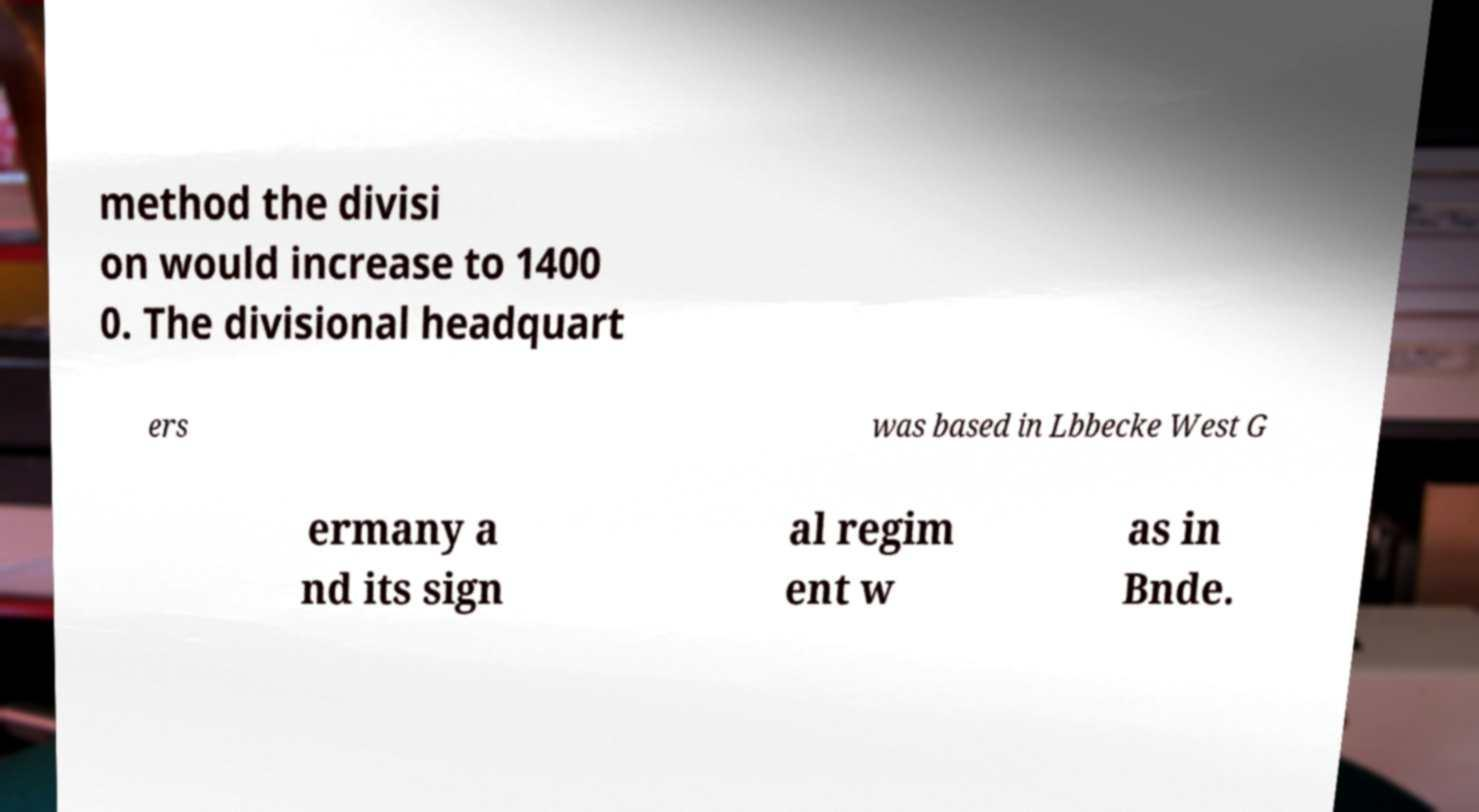Could you assist in decoding the text presented in this image and type it out clearly? method the divisi on would increase to 1400 0. The divisional headquart ers was based in Lbbecke West G ermany a nd its sign al regim ent w as in Bnde. 